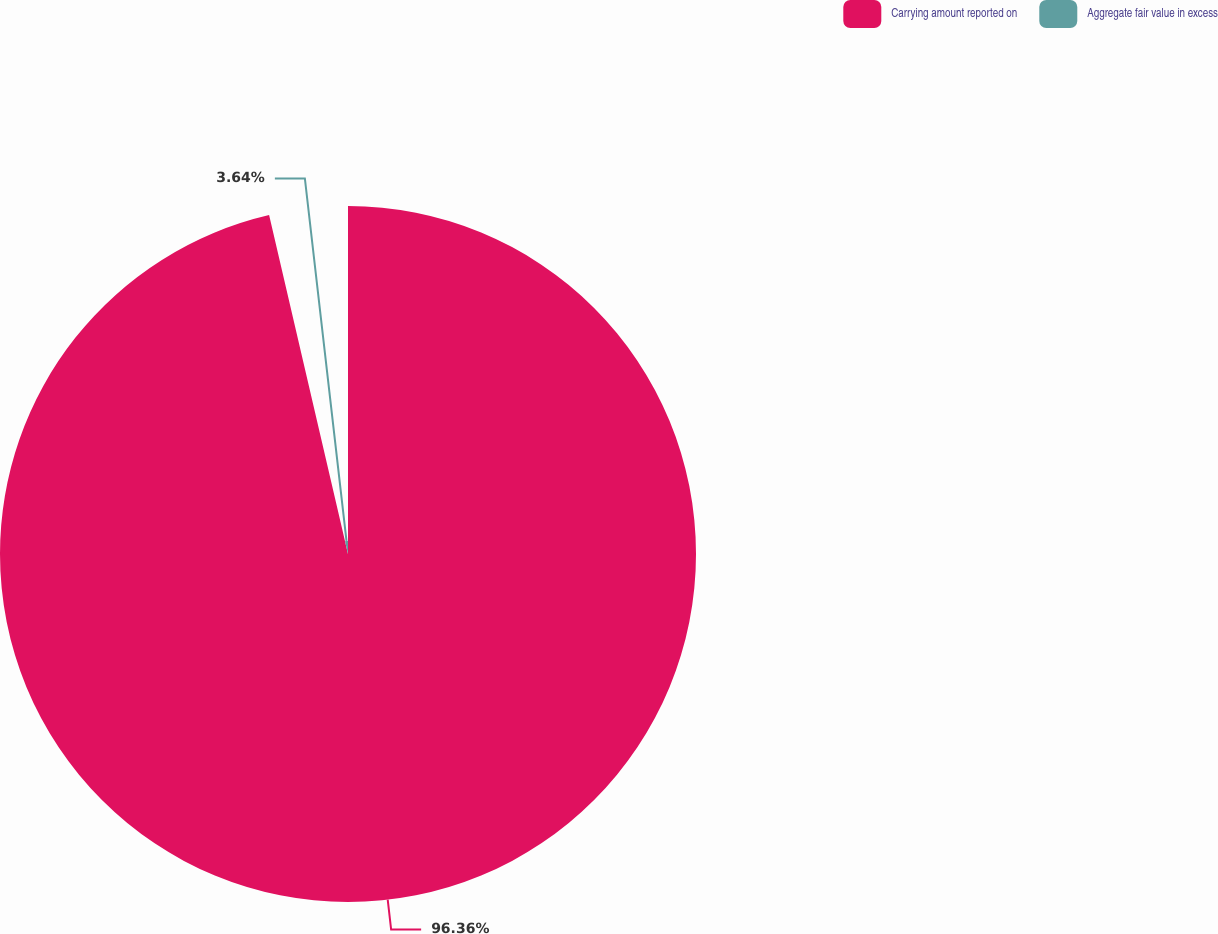<chart> <loc_0><loc_0><loc_500><loc_500><pie_chart><fcel>Carrying amount reported on<fcel>Aggregate fair value in excess<nl><fcel>96.36%<fcel>3.64%<nl></chart> 